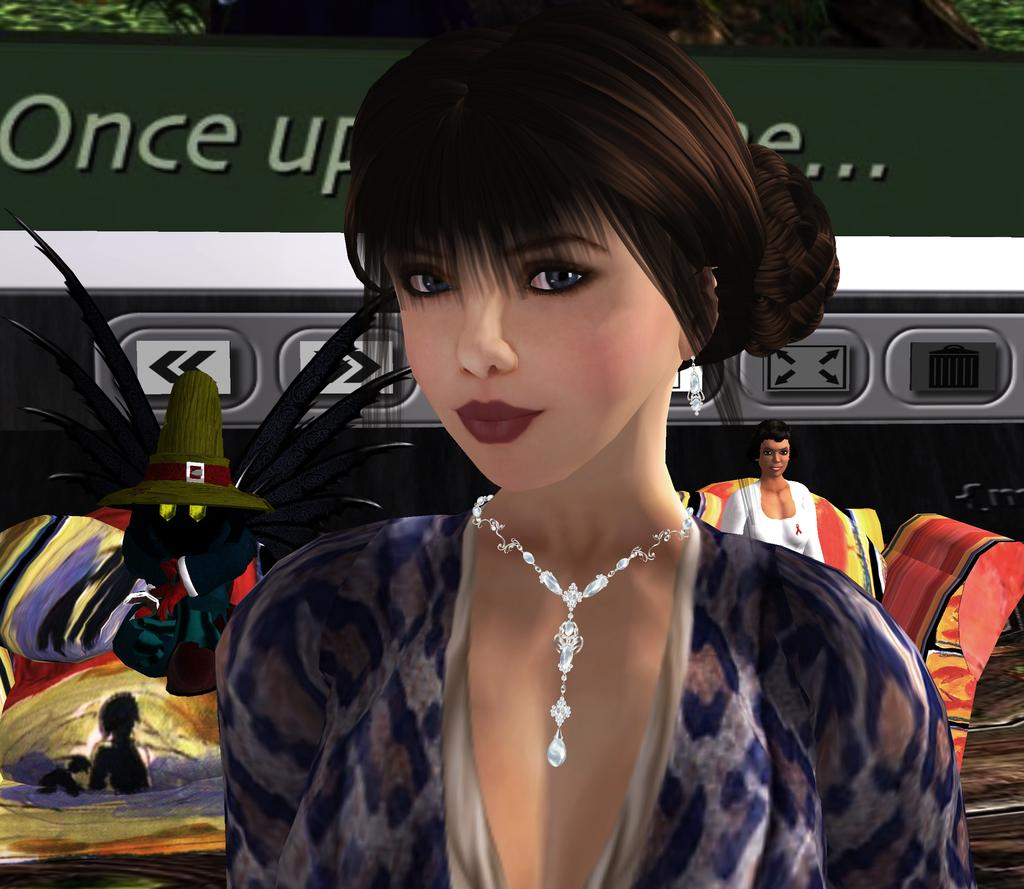What is the gender of the person in the image? The person in the image is a woman. What is the woman doing in the image? The woman is sitting on a chair. Can you describe the background of the image? There are a few things visible in the background of the image. How many girls are sitting on the chair in the image? There is no girl mentioned in the image; it is a woman sitting on the chair. What type of spot is visible on the woman's chair? There is no mention of any spot on the chair in the image. 